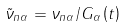<formula> <loc_0><loc_0><loc_500><loc_500>\tilde { \nu } _ { n \alpha } = \nu _ { n \alpha } / G _ { \alpha } \left ( t \right )</formula> 